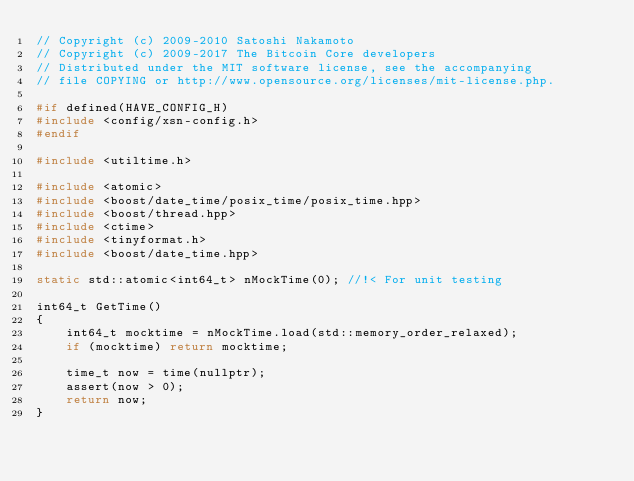<code> <loc_0><loc_0><loc_500><loc_500><_C++_>// Copyright (c) 2009-2010 Satoshi Nakamoto
// Copyright (c) 2009-2017 The Bitcoin Core developers
// Distributed under the MIT software license, see the accompanying
// file COPYING or http://www.opensource.org/licenses/mit-license.php.

#if defined(HAVE_CONFIG_H)
#include <config/xsn-config.h>
#endif

#include <utiltime.h>

#include <atomic>
#include <boost/date_time/posix_time/posix_time.hpp>
#include <boost/thread.hpp>
#include <ctime>
#include <tinyformat.h>
#include <boost/date_time.hpp>

static std::atomic<int64_t> nMockTime(0); //!< For unit testing

int64_t GetTime()
{
    int64_t mocktime = nMockTime.load(std::memory_order_relaxed);
    if (mocktime) return mocktime;

    time_t now = time(nullptr);
    assert(now > 0);
    return now;
}
</code> 